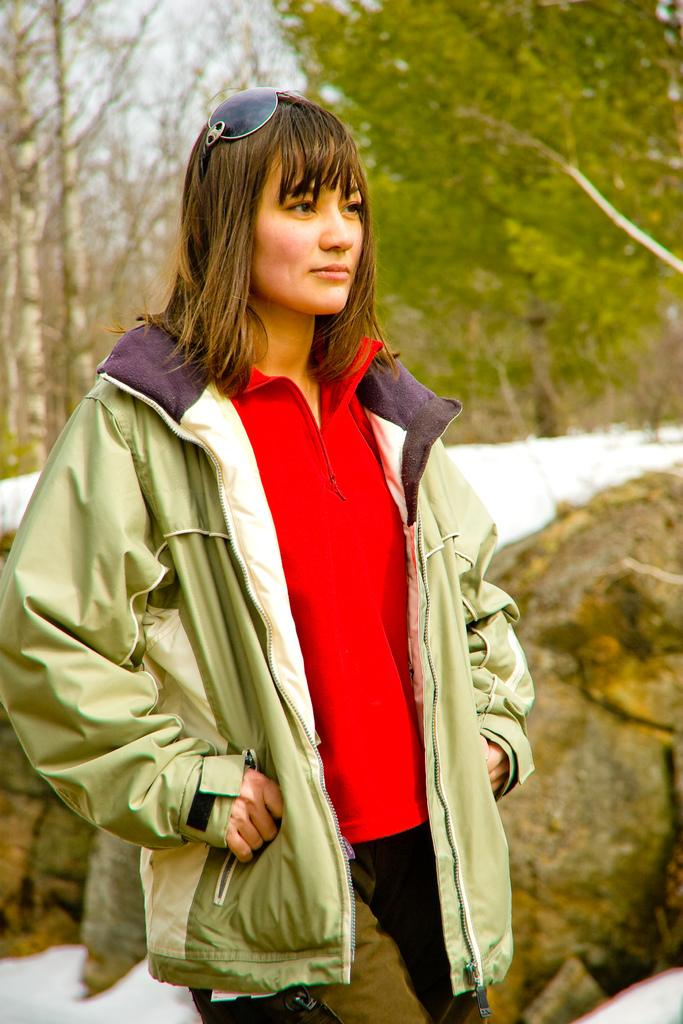Who is the main subject in the picture? There is a woman in the middle of the picture. What is the woman wearing? The woman is wearing a red T-shirt and a green jacket. What is the woman doing in the image? The woman is standing and smiling. What can be seen behind the woman? There are rocks and ice behind the woman, and trees in the background. What type of string is the woman using to play the guitar in the image? There is no guitar present in the image, so there is no string for the woman to use. 